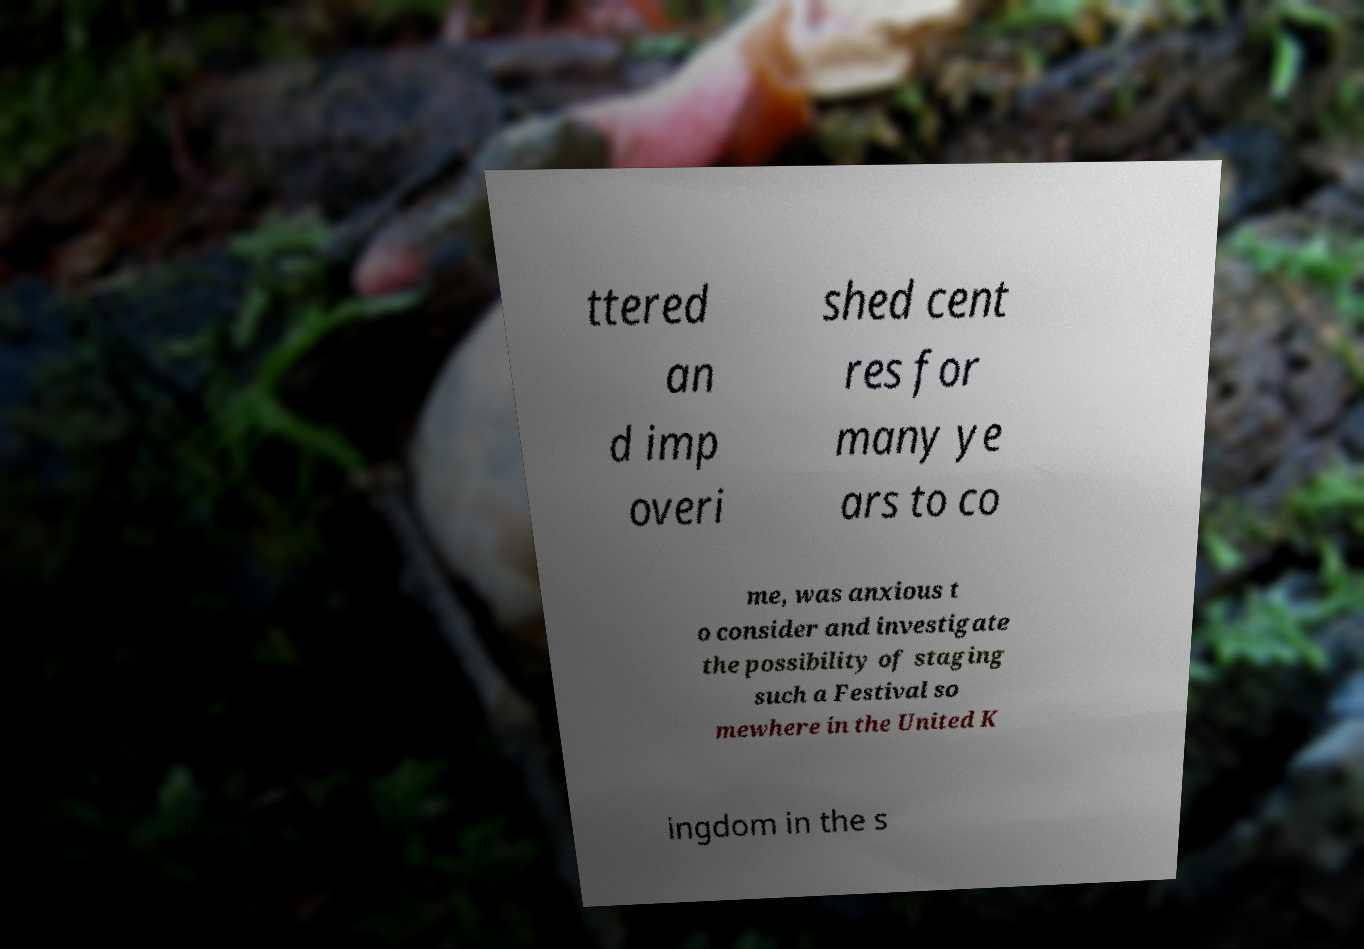Please identify and transcribe the text found in this image. ttered an d imp overi shed cent res for many ye ars to co me, was anxious t o consider and investigate the possibility of staging such a Festival so mewhere in the United K ingdom in the s 